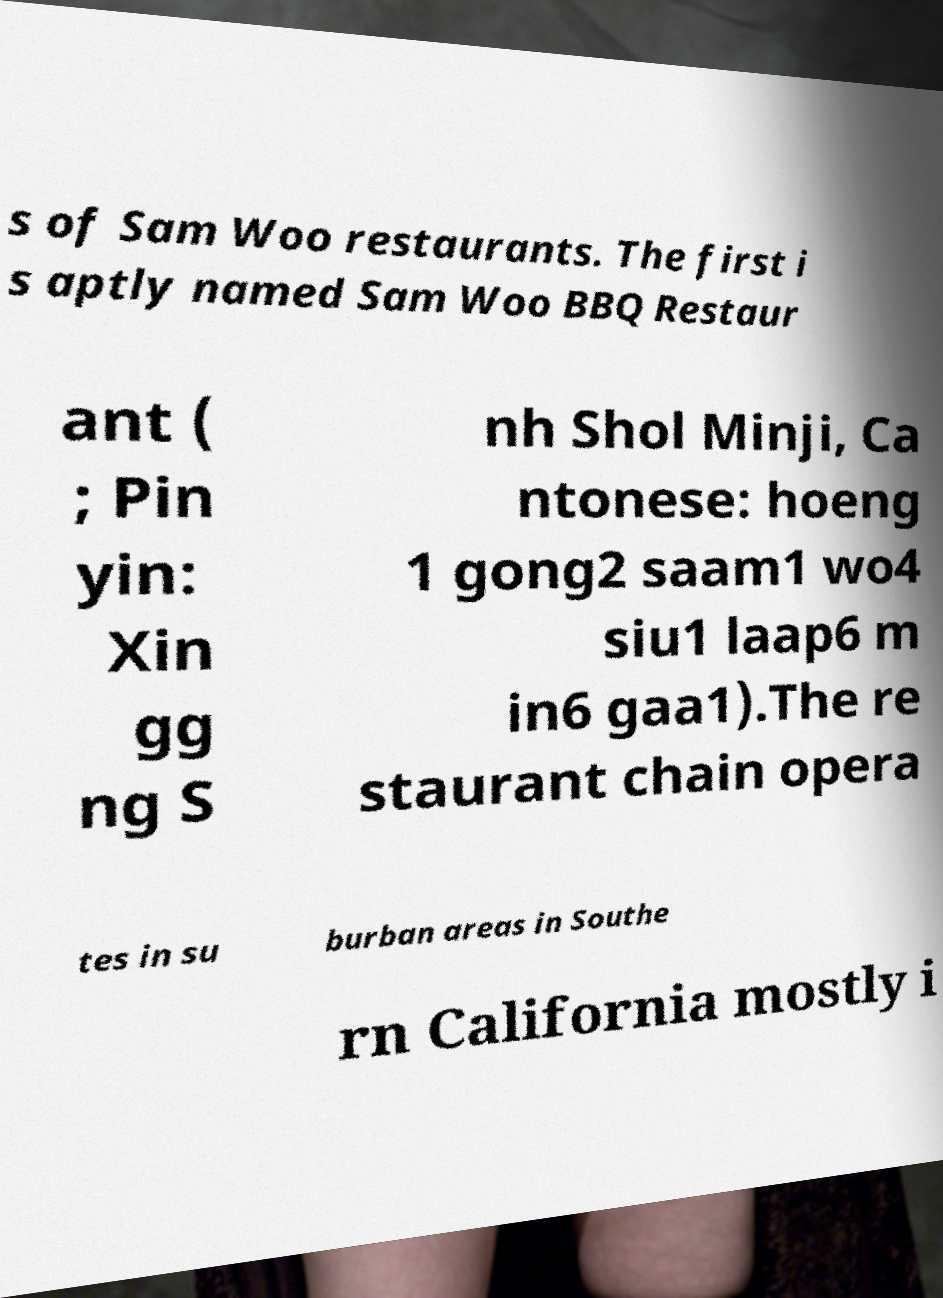Can you read and provide the text displayed in the image?This photo seems to have some interesting text. Can you extract and type it out for me? s of Sam Woo restaurants. The first i s aptly named Sam Woo BBQ Restaur ant ( ; Pin yin: Xin gg ng S nh Shol Minji, Ca ntonese: hoeng 1 gong2 saam1 wo4 siu1 laap6 m in6 gaa1).The re staurant chain opera tes in su burban areas in Southe rn California mostly i 